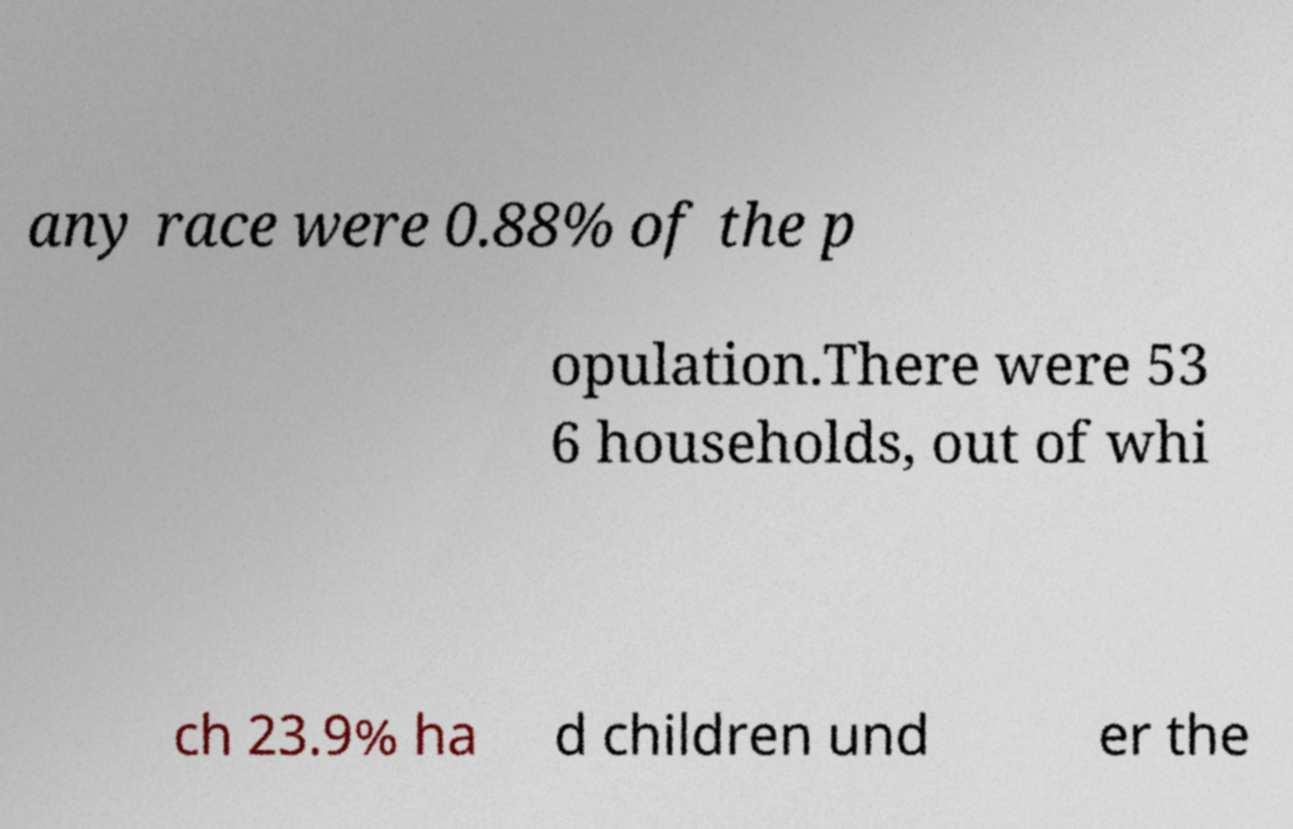For documentation purposes, I need the text within this image transcribed. Could you provide that? any race were 0.88% of the p opulation.There were 53 6 households, out of whi ch 23.9% ha d children und er the 